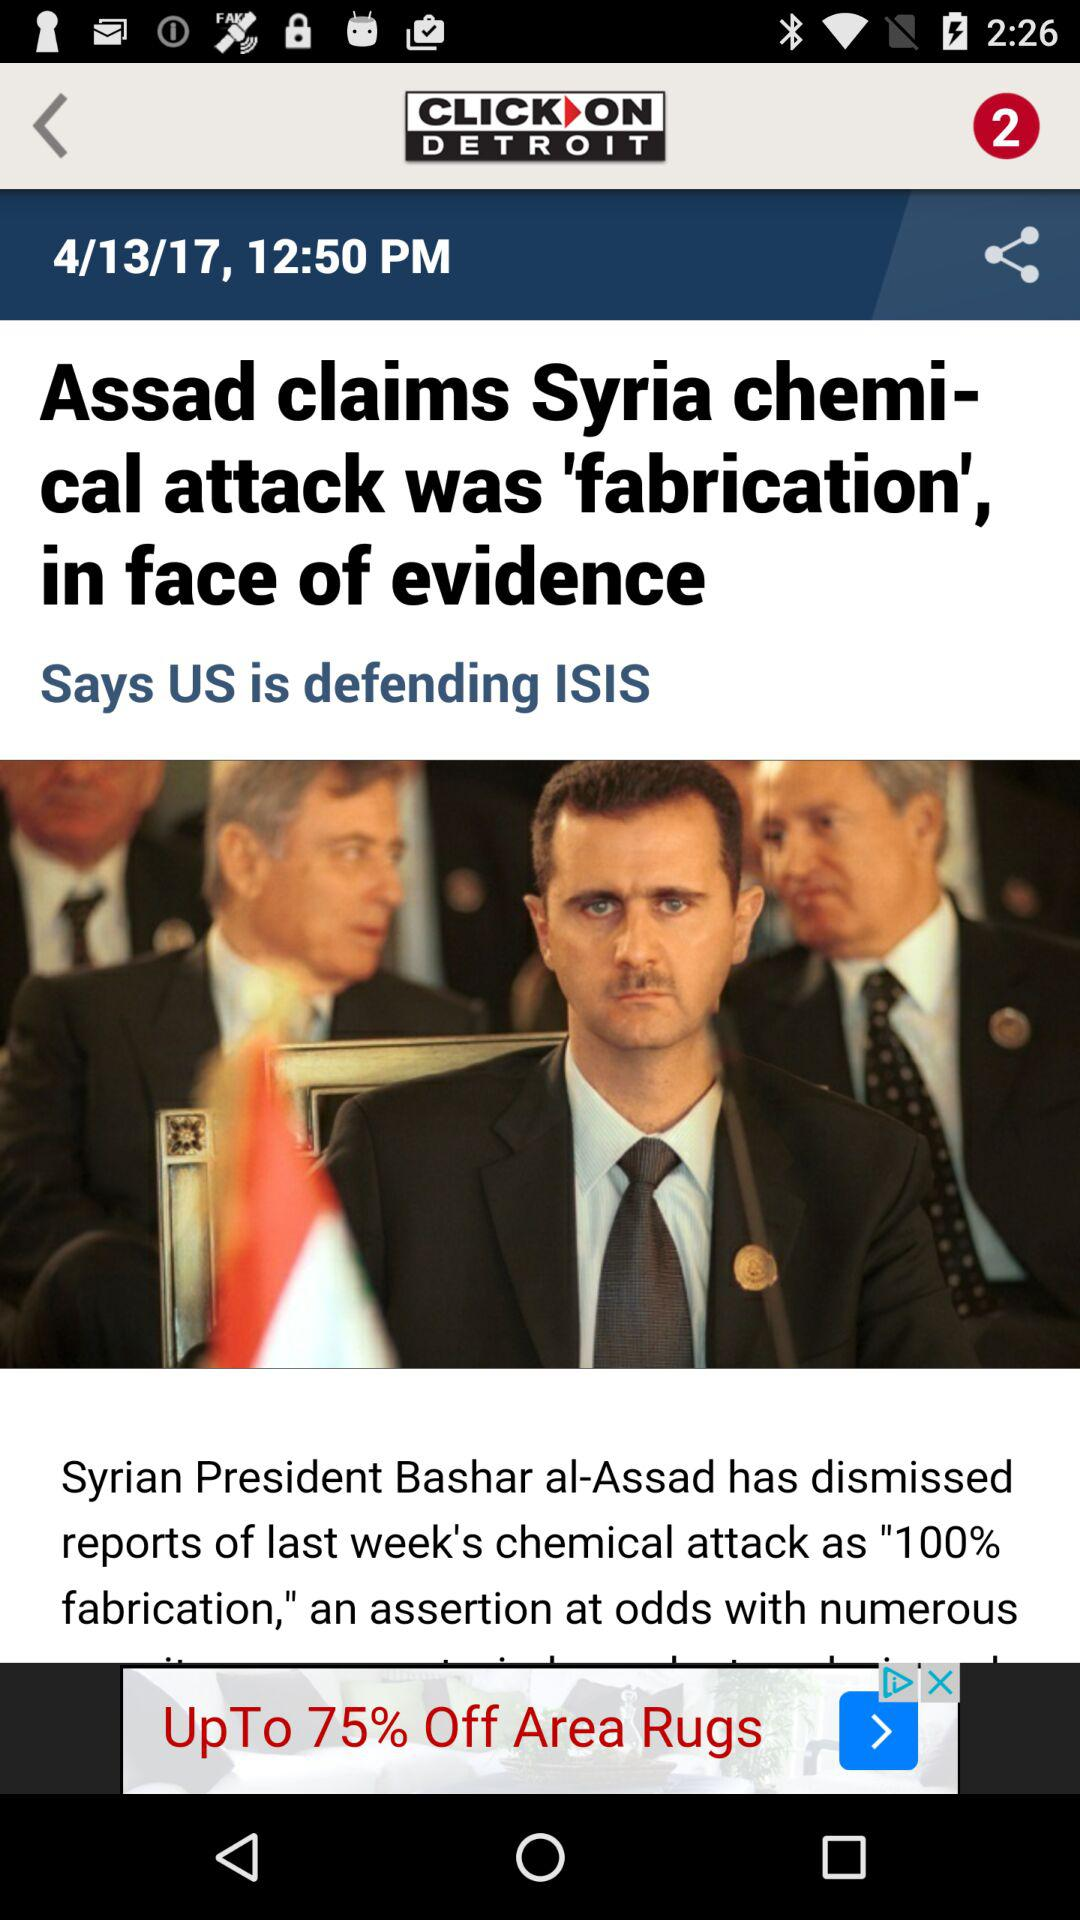What is the given time? The time is 12:50 PM. 